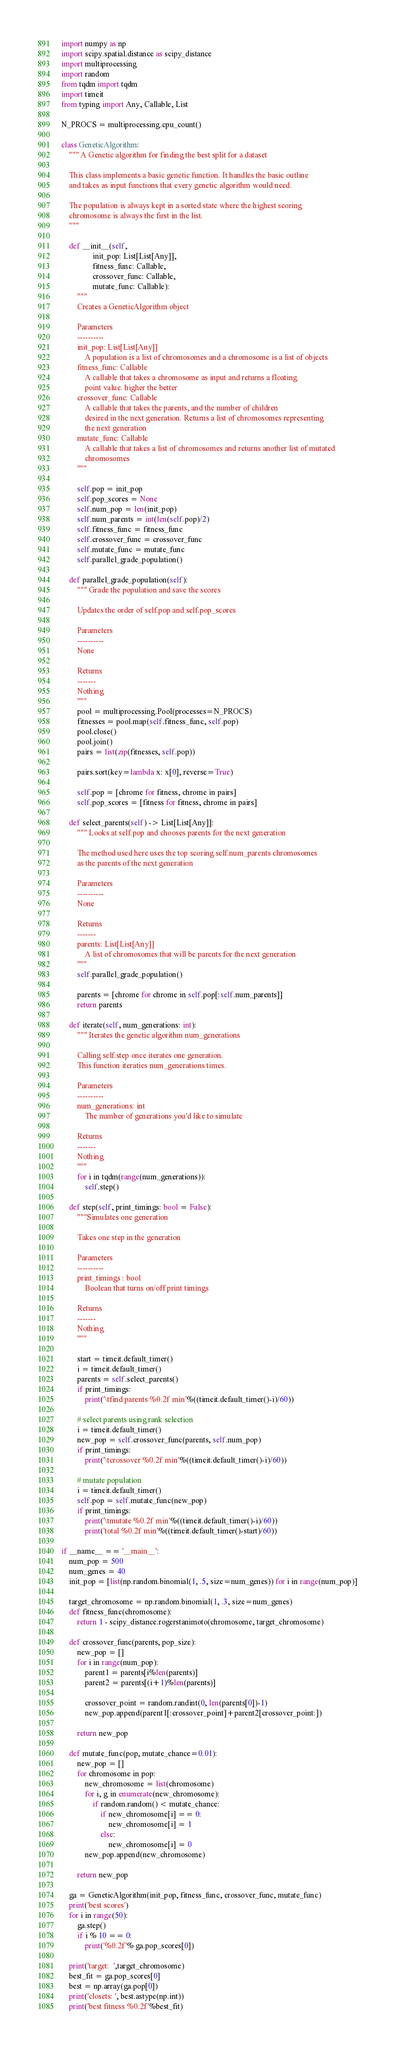Convert code to text. <code><loc_0><loc_0><loc_500><loc_500><_Python_>import numpy as np
import scipy.spatial.distance as scipy_distance
import multiprocessing
import random
from tqdm import tqdm
import timeit
from typing import Any, Callable, List

N_PROCS = multiprocessing.cpu_count()

class GeneticAlgorithm:
    """ A Genetic algorithm for finding the best split for a dataset

    This class implements a basic genetic function. It handles the basic outline
    and takes as input functions that every genetic algorithm would need.

    The population is always kept in a sorted state where the highest scoring
    chromosome is always the first in the list.
    """

    def __init__(self,
                init_pop: List[List[Any]],
                fitness_func: Callable,
                crossover_func: Callable,
                mutate_func: Callable):
        """
        Creates a GeneticAlgorithm object

        Parameters
        ----------
        init_pop: List[List[Any]]
            A population is a list of chromosomes and a chromosome is a list of objects
        fitness_func: Callable
            A callable that takes a chromosome as input and returns a floating
            point value. higher the better
        crossover_func: Callable
            A callable that takes the parents, and the number of children
            desired in the next generation. Returns a list of chromosomes representing
            the next generation
        mutate_func: Callable
            A callable that takes a list of chromosomes and returns another list of mutated 
            chromosomes
        """

        self.pop = init_pop
        self.pop_scores = None
        self.num_pop = len(init_pop)
        self.num_parents = int(len(self.pop)/2)
        self.fitness_func = fitness_func
        self.crossover_func = crossover_func
        self.mutate_func = mutate_func
        self.parallel_grade_population()

    def parallel_grade_population(self):
        """ Grade the population and save the scores

        Updates the order of self.pop and self.pop_scores

        Parameters
        ----------
        None

        Returns
        -------
        Nothing
        """
        pool = multiprocessing.Pool(processes=N_PROCS)
        fitnesses = pool.map(self.fitness_func, self.pop)
        pool.close()
        pool.join()
        pairs = list(zip(fitnesses, self.pop))

        pairs.sort(key=lambda x: x[0], reverse=True)

        self.pop = [chrome for fitness, chrome in pairs]
        self.pop_scores = [fitness for fitness, chrome in pairs]

    def select_parents(self) -> List[List[Any]]:
        """ Looks at self.pop and chooses parents for the next generation

        The method used here uses the top scoring self.num_parents chromosomes
        as the parents of the next generation

        Parameters
        ----------
        None

        Returns
        -------
        parents: List[List[Any]]
            A list of chromosomes that will be parents for the next generation
        """
        self.parallel_grade_population()

        parents = [chrome for chrome in self.pop[:self.num_parents]]
        return parents

    def iterate(self, num_generations: int):
        """ Iterates the genetic algorithm num_generations

        Calling self.step once iterates one generation. 
        This function iteraties num_generations times.

        Parameters
        ----------
        num_generations: int
            The number of generations you'd like to simulate

        Returns
        -------
        Nothing
        """
        for i in tqdm(range(num_generations)):
            self.step()

    def step(self, print_timings: bool = False):
        """Simulates one generation

        Takes one step in the generation

        Parameters
        ----------
        print_timings : bool
            Boolean that turns on/off print timings

        Returns
        -------
        Nothing
        """

        start = timeit.default_timer()
        i = timeit.default_timer()
        parents = self.select_parents()
        if print_timings:
            print('\tfind parents %0.2f min'%((timeit.default_timer()-i)/60))

        # select parents using rank selection
        i = timeit.default_timer()
        new_pop = self.crossover_func(parents, self.num_pop)
        if print_timings:
            print('\tcrossover %0.2f min'%((timeit.default_timer()-i)/60))

        # mutate population
        i = timeit.default_timer()
        self.pop = self.mutate_func(new_pop)
        if print_timings:
            print('\tmutate %0.2f min'%((timeit.default_timer()-i)/60))
            print('total %0.2f min'%((timeit.default_timer()-start)/60))

if __name__ == '__main__':
    num_pop = 500
    num_genes = 40
    init_pop = [list(np.random.binomial(1, .5, size=num_genes)) for i in range(num_pop)]

    target_chromosome = np.random.binomial(1, .3, size=num_genes)
    def fitness_func(chromosome):
        return 1 - scipy_distance.rogerstanimoto(chromosome, target_chromosome)

    def crossover_func(parents, pop_size):
        new_pop = []
        for i in range(num_pop):
            parent1 = parents[i%len(parents)]
            parent2 = parents[(i+1)%len(parents)]

            crossover_point = random.randint(0, len(parents[0])-1)
            new_pop.append(parent1[:crossover_point]+parent2[crossover_point:])

        return new_pop

    def mutate_func(pop, mutate_chance=0.01):
        new_pop = []
        for chromosome in pop:
            new_chromosome = list(chromosome)
            for i, g in enumerate(new_chromosome):
                if random.random() < mutate_chance:
                    if new_chromosome[i] == 0:
                        new_chromosome[i] = 1
                    else:
                        new_chromosome[i] = 0
            new_pop.append(new_chromosome)

        return new_pop

    ga = GeneticAlgorithm(init_pop, fitness_func, crossover_func, mutate_func)
    print('best scores')
    for i in range(50):
        ga.step()
        if i % 10 == 0:
            print('%0.2f'% ga.pop_scores[0])

    print('target:  ',target_chromosome)
    best_fit = ga.pop_scores[0]
    best = np.array(ga.pop[0])
    print('closets: ', best.astype(np.int))
    print('best fitness %0.2f'%best_fit)
</code> 